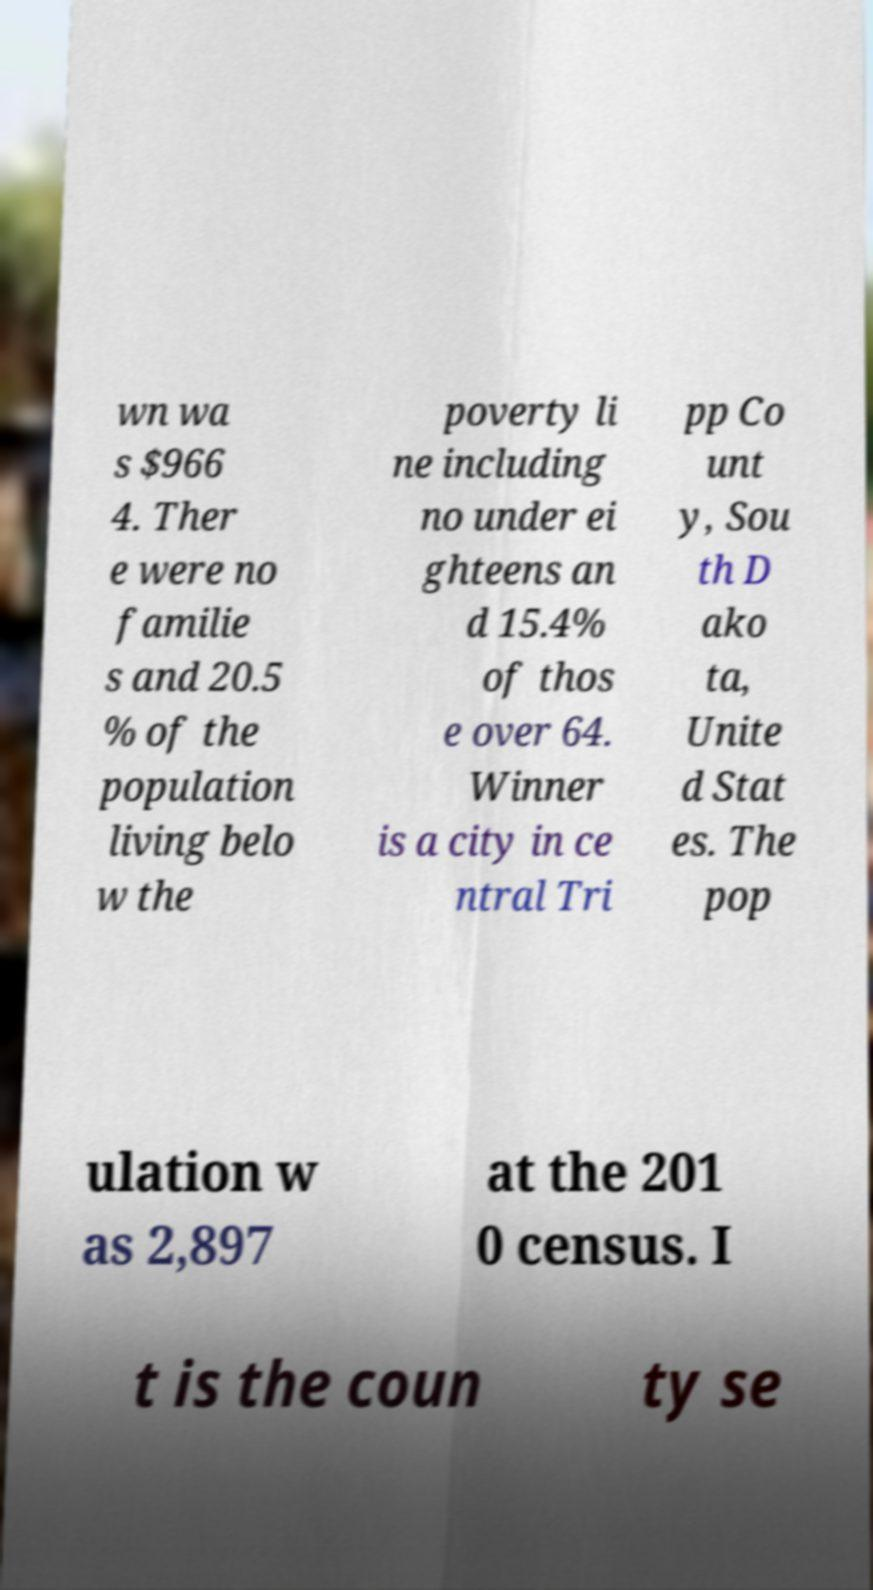Please read and relay the text visible in this image. What does it say? wn wa s $966 4. Ther e were no familie s and 20.5 % of the population living belo w the poverty li ne including no under ei ghteens an d 15.4% of thos e over 64. Winner is a city in ce ntral Tri pp Co unt y, Sou th D ako ta, Unite d Stat es. The pop ulation w as 2,897 at the 201 0 census. I t is the coun ty se 